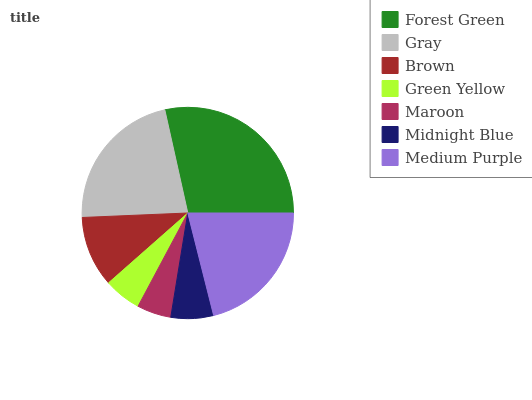Is Maroon the minimum?
Answer yes or no. Yes. Is Forest Green the maximum?
Answer yes or no. Yes. Is Gray the minimum?
Answer yes or no. No. Is Gray the maximum?
Answer yes or no. No. Is Forest Green greater than Gray?
Answer yes or no. Yes. Is Gray less than Forest Green?
Answer yes or no. Yes. Is Gray greater than Forest Green?
Answer yes or no. No. Is Forest Green less than Gray?
Answer yes or no. No. Is Brown the high median?
Answer yes or no. Yes. Is Brown the low median?
Answer yes or no. Yes. Is Forest Green the high median?
Answer yes or no. No. Is Medium Purple the low median?
Answer yes or no. No. 